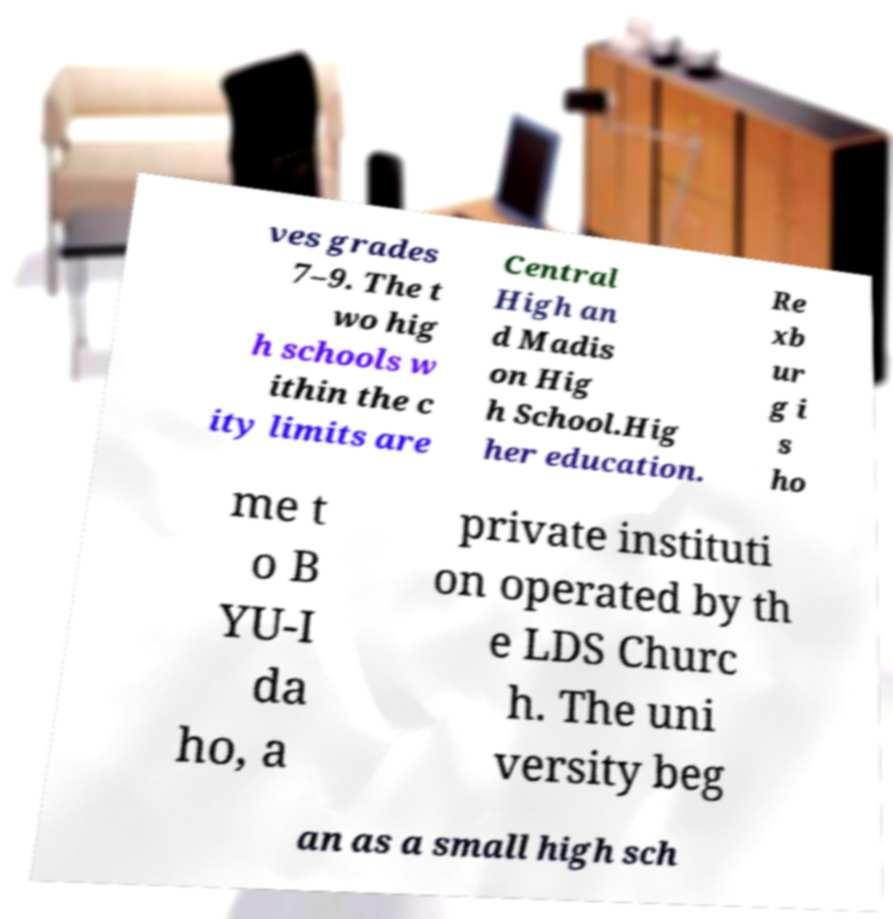Could you assist in decoding the text presented in this image and type it out clearly? ves grades 7–9. The t wo hig h schools w ithin the c ity limits are Central High an d Madis on Hig h School.Hig her education. Re xb ur g i s ho me t o B YU-I da ho, a private instituti on operated by th e LDS Churc h. The uni versity beg an as a small high sch 